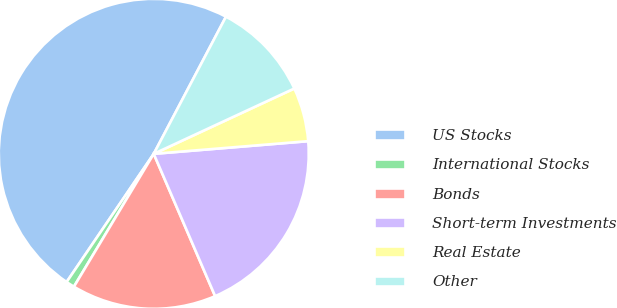Convert chart to OTSL. <chart><loc_0><loc_0><loc_500><loc_500><pie_chart><fcel>US Stocks<fcel>International Stocks<fcel>Bonds<fcel>Short-term Investments<fcel>Real Estate<fcel>Other<nl><fcel>48.21%<fcel>0.89%<fcel>15.09%<fcel>19.82%<fcel>5.62%<fcel>10.36%<nl></chart> 